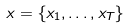<formula> <loc_0><loc_0><loc_500><loc_500>x = \{ x _ { 1 } , \dots , x _ { T } \}</formula> 